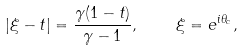<formula> <loc_0><loc_0><loc_500><loc_500>| \xi - t | = \frac { \gamma ( 1 - t ) } { \gamma - 1 } , \quad \xi = e ^ { i \theta _ { c } } ,</formula> 